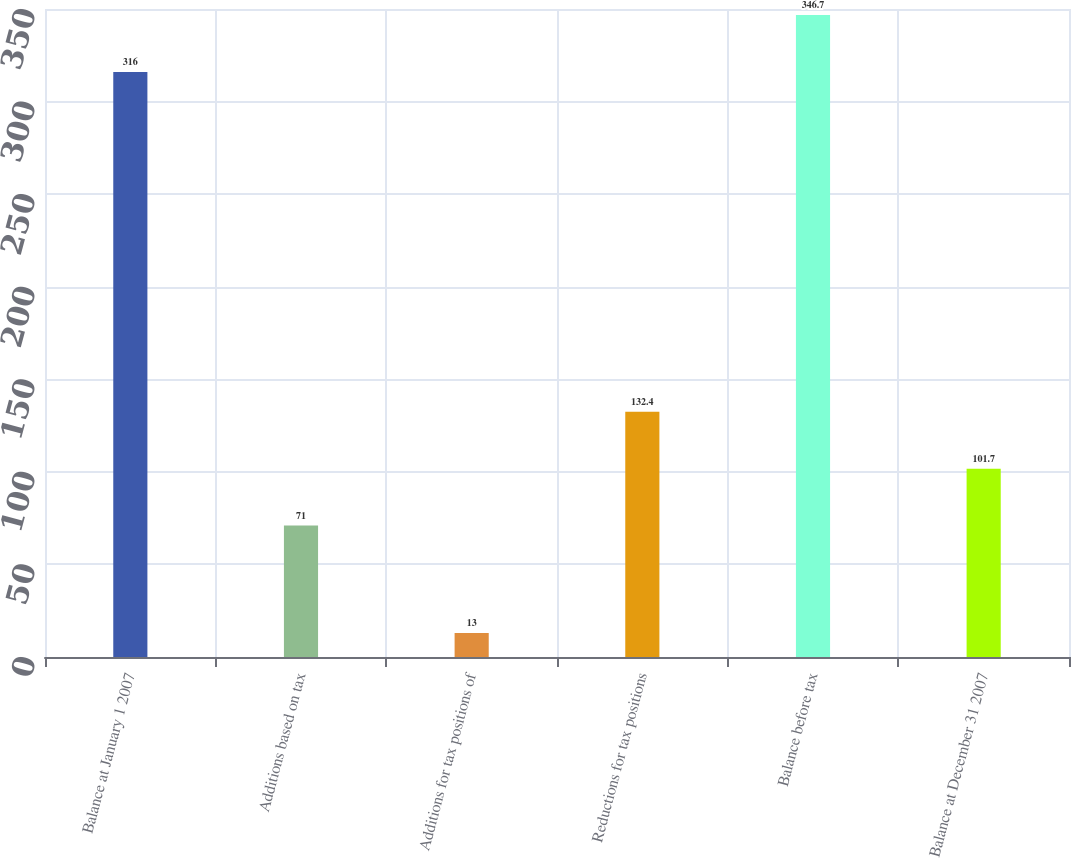Convert chart. <chart><loc_0><loc_0><loc_500><loc_500><bar_chart><fcel>Balance at January 1 2007<fcel>Additions based on tax<fcel>Additions for tax positions of<fcel>Reductions for tax positions<fcel>Balance before tax<fcel>Balance at December 31 2007<nl><fcel>316<fcel>71<fcel>13<fcel>132.4<fcel>346.7<fcel>101.7<nl></chart> 